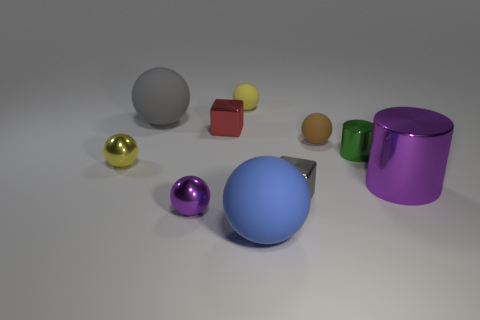What is the shape of the metal thing that is right of the gray metallic thing and behind the large purple object?
Your answer should be very brief. Cylinder. What is the material of the ball that is the same color as the big metallic cylinder?
Your answer should be very brief. Metal. What number of blocks are large purple metal objects or big gray things?
Your answer should be very brief. 0. There is another object that is the same color as the large metal thing; what is its size?
Give a very brief answer. Small. Is the number of large gray things that are to the left of the gray matte sphere less than the number of blue balls?
Your answer should be compact. Yes. There is a small shiny object that is both on the left side of the tiny gray cube and in front of the large purple cylinder; what color is it?
Offer a terse response. Purple. What number of other things are the same shape as the tiny gray thing?
Keep it short and to the point. 1. Are there fewer big balls that are to the right of the red metal object than balls that are behind the small green metallic cylinder?
Offer a terse response. Yes. Does the large purple thing have the same material as the small sphere in front of the big cylinder?
Your answer should be compact. Yes. Are there any other things that have the same material as the big gray thing?
Provide a succinct answer. Yes. 